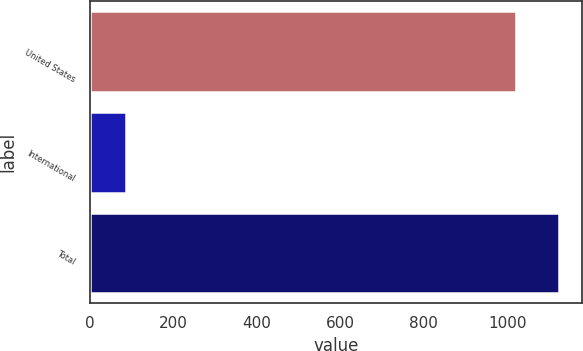Convert chart. <chart><loc_0><loc_0><loc_500><loc_500><bar_chart><fcel>United States<fcel>International<fcel>Total<nl><fcel>1021.4<fcel>87.4<fcel>1123.54<nl></chart> 